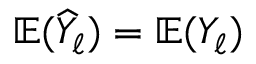Convert formula to latex. <formula><loc_0><loc_0><loc_500><loc_500>\mathbb { E } ( \widehat { Y } _ { \ell } ) = \mathbb { E } ( Y _ { \ell } )</formula> 